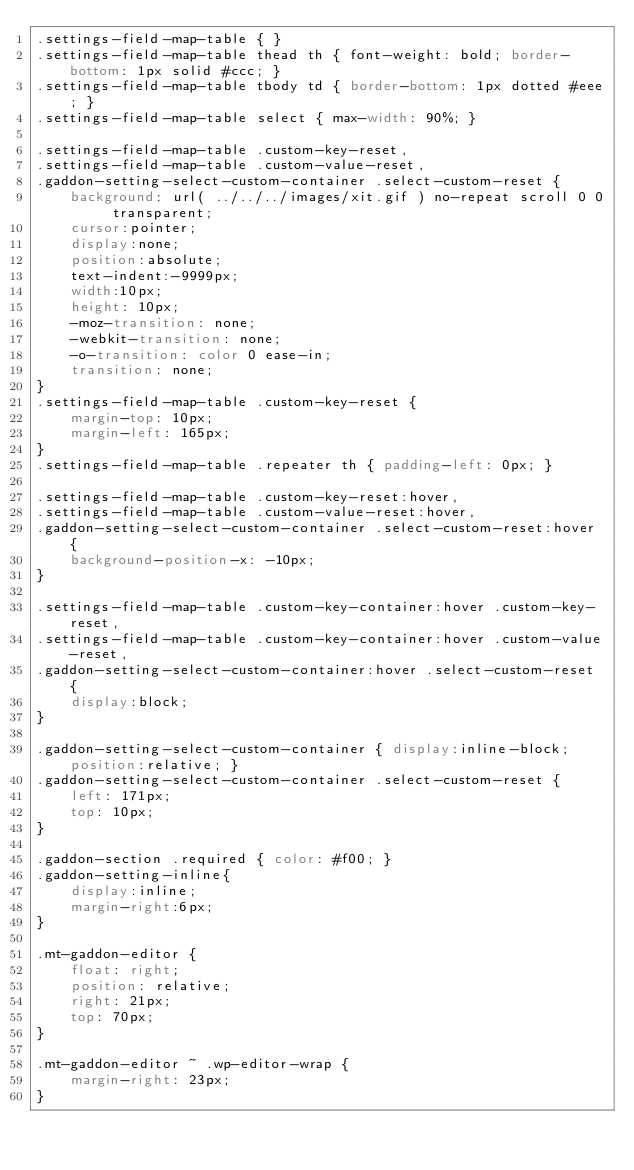Convert code to text. <code><loc_0><loc_0><loc_500><loc_500><_CSS_>.settings-field-map-table { }
.settings-field-map-table thead th { font-weight: bold; border-bottom: 1px solid #ccc; }
.settings-field-map-table tbody td { border-bottom: 1px dotted #eee; }
.settings-field-map-table select { max-width: 90%; }

.settings-field-map-table .custom-key-reset,
.settings-field-map-table .custom-value-reset,
.gaddon-setting-select-custom-container .select-custom-reset {
	background: url( ../../../images/xit.gif ) no-repeat scroll 0 0 transparent;
	cursor:pointer;
	display:none;
	position:absolute;
	text-indent:-9999px;
	width:10px;
	height: 10px;
	-moz-transition: none;
	-webkit-transition: none;
	-o-transition: color 0 ease-in;
	transition: none;
}
.settings-field-map-table .custom-key-reset {
	margin-top: 10px;
	margin-left: 165px;
}
.settings-field-map-table .repeater th { padding-left: 0px; }

.settings-field-map-table .custom-key-reset:hover,
.settings-field-map-table .custom-value-reset:hover,
.gaddon-setting-select-custom-container .select-custom-reset:hover {
	background-position-x: -10px;
}

.settings-field-map-table .custom-key-container:hover .custom-key-reset,
.settings-field-map-table .custom-key-container:hover .custom-value-reset,
.gaddon-setting-select-custom-container:hover .select-custom-reset {
	display:block;
}

.gaddon-setting-select-custom-container { display:inline-block;position:relative; }
.gaddon-setting-select-custom-container .select-custom-reset {
	left: 171px;
	top: 10px;
}

.gaddon-section .required { color: #f00; }
.gaddon-setting-inline{
    display:inline;
    margin-right:6px;
}

.mt-gaddon-editor {
	float: right;
	position: relative;
	right: 21px;
	top: 70px;
}

.mt-gaddon-editor ~ .wp-editor-wrap {
	margin-right: 23px;
}</code> 